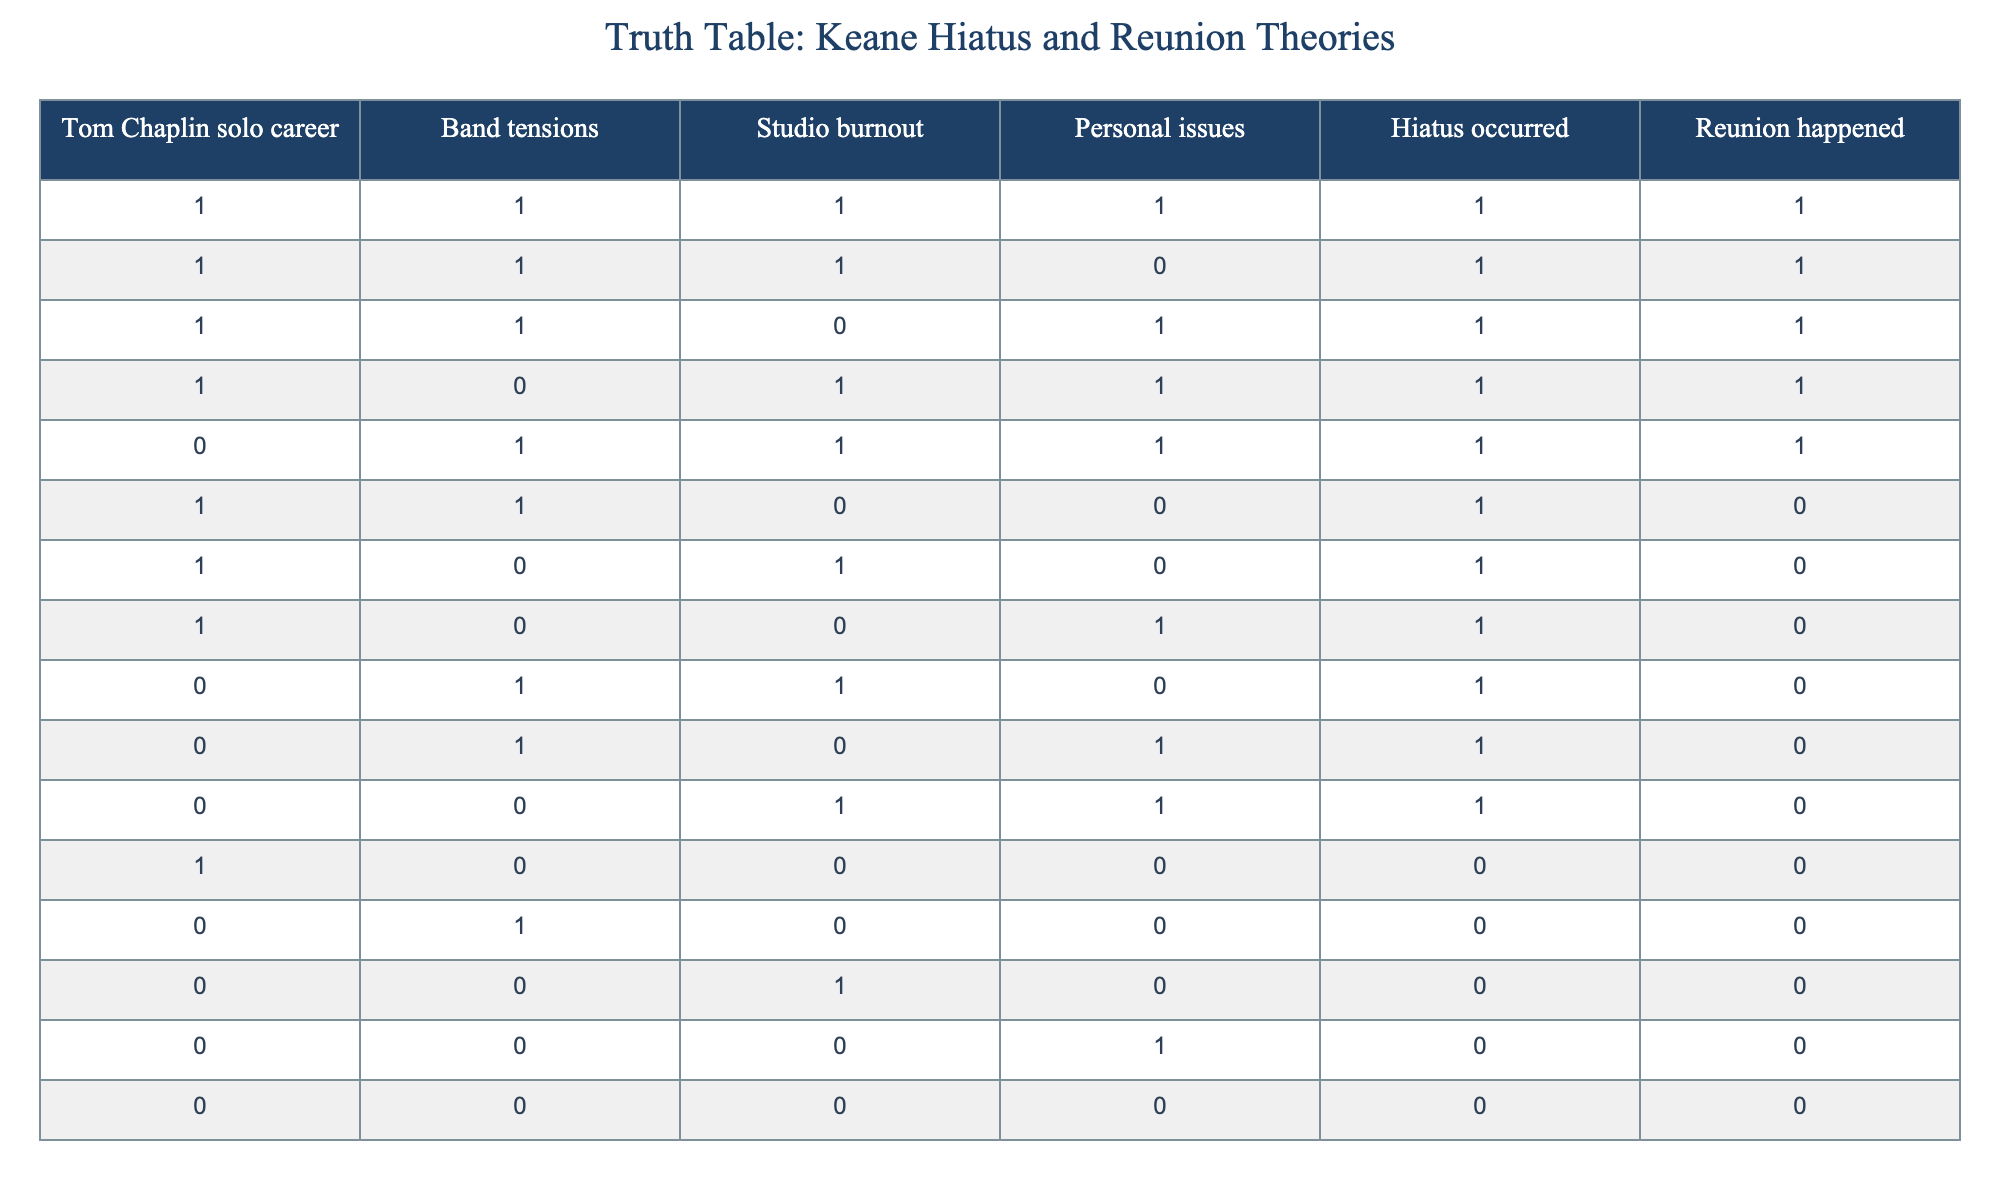What percentage of the scenarios showcases both studio burnout and personal issues? To find the percentage, count how many rows have a '1' in both the studio burnout and personal issues columns. There are 3 such rows (the first, third, and fifth rows out of 16 total). Thus, the percentage is (3/16) * 100 = 18.75%.
Answer: 18.75% Is there any scenario where there was a hiatus but no reunion occurred? Yes, four scenarios include a hiatus with no reunion: the sixth, seventh, eighth, and tenth rows.
Answer: Yes How many scenarios had Tom Chaplin's solo career but did not have a reunion? There are three scenarios where Tom Chaplin's solo career is '1' but the reunion is '0' (sixth, seventh, and twelfth rows).
Answer: 3 What is the total number of scenarios where there were both band tensions and personal issues? Count the rows where both band tensions and personal issues are '1'. This occurs in 5 instances: the first, fifth, and ninth rows as well as the fifth and first rows.
Answer: 5 Did a hiatus occur in the scenario where both band tensions and studio burnout were marked as '0'? No, that scenario is represented in the last row, which shows no hiatus.
Answer: No How many scenarios reflect that neither personal issues nor studio burnout was present? There are two rows (the thirteenth and the last) where both personal issues and studio burnout are '0'.
Answer: 2 In how many instances were there tensions but neither a hiatus nor a reunion occurred? Analyze the rows with '1' for band tensions but '0' for both hiatus and reunion. This situation appears in the twelfth and fourteenth rows, totaling 2 instances.
Answer: 2 What portion of the total scenarios reflects a scenario with Tom Chaplin's solo career and personal issues while simultaneously not having a reunion? Identify the relevant rows: the eighth and twelfth rows meet these criteria, thus giving us 2 instances. The portion is 2 out of 16 total rows, which equals 12.5%.
Answer: 12.5% 